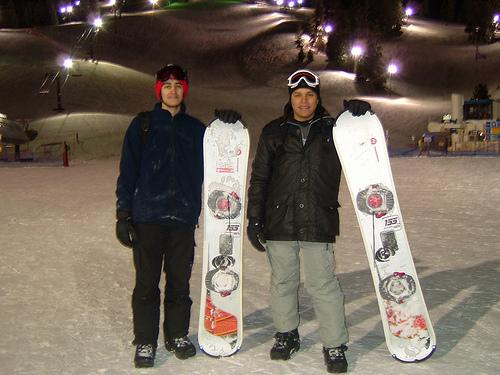Why are the lights on at this ski resort?

Choices:
A) it's raining
B) it's cloudy
C) it's storming
D) it's night it's night 